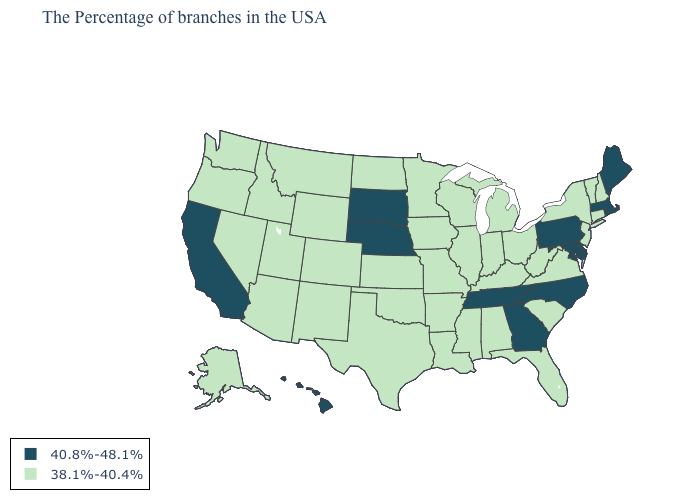Name the states that have a value in the range 40.8%-48.1%?
Write a very short answer. Maine, Massachusetts, Rhode Island, Delaware, Maryland, Pennsylvania, North Carolina, Georgia, Tennessee, Nebraska, South Dakota, California, Hawaii. What is the value of South Dakota?
Write a very short answer. 40.8%-48.1%. Name the states that have a value in the range 38.1%-40.4%?
Keep it brief. New Hampshire, Vermont, Connecticut, New York, New Jersey, Virginia, South Carolina, West Virginia, Ohio, Florida, Michigan, Kentucky, Indiana, Alabama, Wisconsin, Illinois, Mississippi, Louisiana, Missouri, Arkansas, Minnesota, Iowa, Kansas, Oklahoma, Texas, North Dakota, Wyoming, Colorado, New Mexico, Utah, Montana, Arizona, Idaho, Nevada, Washington, Oregon, Alaska. Does Kansas have a lower value than Pennsylvania?
Quick response, please. Yes. Does Idaho have the highest value in the USA?
Keep it brief. No. How many symbols are there in the legend?
Keep it brief. 2. What is the value of South Carolina?
Short answer required. 38.1%-40.4%. What is the highest value in states that border Arizona?
Be succinct. 40.8%-48.1%. Does the first symbol in the legend represent the smallest category?
Answer briefly. No. Among the states that border Texas , which have the lowest value?
Answer briefly. Louisiana, Arkansas, Oklahoma, New Mexico. Does Vermont have a lower value than Alabama?
Be succinct. No. Which states hav the highest value in the South?
Answer briefly. Delaware, Maryland, North Carolina, Georgia, Tennessee. Which states have the lowest value in the USA?
Concise answer only. New Hampshire, Vermont, Connecticut, New York, New Jersey, Virginia, South Carolina, West Virginia, Ohio, Florida, Michigan, Kentucky, Indiana, Alabama, Wisconsin, Illinois, Mississippi, Louisiana, Missouri, Arkansas, Minnesota, Iowa, Kansas, Oklahoma, Texas, North Dakota, Wyoming, Colorado, New Mexico, Utah, Montana, Arizona, Idaho, Nevada, Washington, Oregon, Alaska. What is the value of Missouri?
Quick response, please. 38.1%-40.4%. What is the value of Alaska?
Quick response, please. 38.1%-40.4%. 